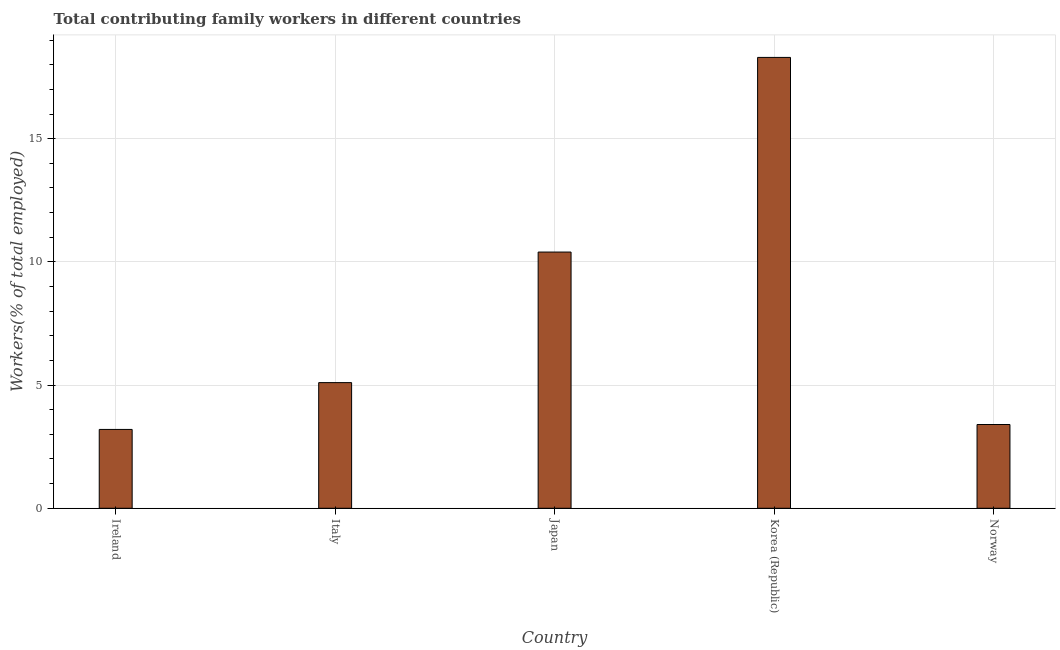What is the title of the graph?
Offer a very short reply. Total contributing family workers in different countries. What is the label or title of the Y-axis?
Your answer should be very brief. Workers(% of total employed). What is the contributing family workers in Norway?
Give a very brief answer. 3.4. Across all countries, what is the maximum contributing family workers?
Provide a succinct answer. 18.3. Across all countries, what is the minimum contributing family workers?
Offer a very short reply. 3.2. In which country was the contributing family workers minimum?
Offer a very short reply. Ireland. What is the sum of the contributing family workers?
Provide a succinct answer. 40.4. What is the difference between the contributing family workers in Korea (Republic) and Norway?
Offer a terse response. 14.9. What is the average contributing family workers per country?
Ensure brevity in your answer.  8.08. What is the median contributing family workers?
Offer a very short reply. 5.1. What is the ratio of the contributing family workers in Ireland to that in Japan?
Your answer should be very brief. 0.31. What is the difference between the highest and the lowest contributing family workers?
Ensure brevity in your answer.  15.1. How many bars are there?
Your answer should be compact. 5. Are all the bars in the graph horizontal?
Provide a short and direct response. No. How many countries are there in the graph?
Offer a terse response. 5. What is the difference between two consecutive major ticks on the Y-axis?
Your answer should be very brief. 5. What is the Workers(% of total employed) of Ireland?
Keep it short and to the point. 3.2. What is the Workers(% of total employed) of Italy?
Keep it short and to the point. 5.1. What is the Workers(% of total employed) in Japan?
Provide a succinct answer. 10.4. What is the Workers(% of total employed) of Korea (Republic)?
Offer a very short reply. 18.3. What is the Workers(% of total employed) of Norway?
Provide a succinct answer. 3.4. What is the difference between the Workers(% of total employed) in Ireland and Japan?
Keep it short and to the point. -7.2. What is the difference between the Workers(% of total employed) in Ireland and Korea (Republic)?
Offer a terse response. -15.1. What is the difference between the Workers(% of total employed) in Japan and Norway?
Give a very brief answer. 7. What is the difference between the Workers(% of total employed) in Korea (Republic) and Norway?
Ensure brevity in your answer.  14.9. What is the ratio of the Workers(% of total employed) in Ireland to that in Italy?
Give a very brief answer. 0.63. What is the ratio of the Workers(% of total employed) in Ireland to that in Japan?
Your response must be concise. 0.31. What is the ratio of the Workers(% of total employed) in Ireland to that in Korea (Republic)?
Provide a short and direct response. 0.17. What is the ratio of the Workers(% of total employed) in Ireland to that in Norway?
Your answer should be very brief. 0.94. What is the ratio of the Workers(% of total employed) in Italy to that in Japan?
Your response must be concise. 0.49. What is the ratio of the Workers(% of total employed) in Italy to that in Korea (Republic)?
Provide a succinct answer. 0.28. What is the ratio of the Workers(% of total employed) in Italy to that in Norway?
Keep it short and to the point. 1.5. What is the ratio of the Workers(% of total employed) in Japan to that in Korea (Republic)?
Give a very brief answer. 0.57. What is the ratio of the Workers(% of total employed) in Japan to that in Norway?
Keep it short and to the point. 3.06. What is the ratio of the Workers(% of total employed) in Korea (Republic) to that in Norway?
Offer a very short reply. 5.38. 